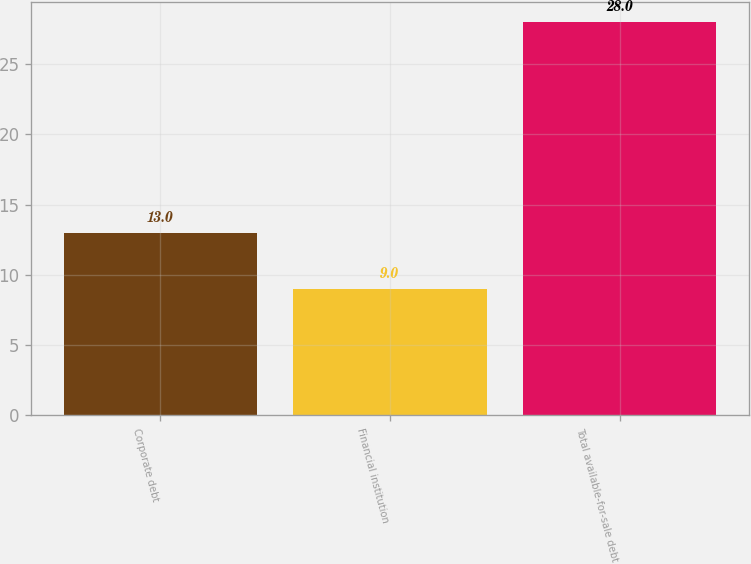Convert chart to OTSL. <chart><loc_0><loc_0><loc_500><loc_500><bar_chart><fcel>Corporate debt<fcel>Financial institution<fcel>Total available-for-sale debt<nl><fcel>13<fcel>9<fcel>28<nl></chart> 